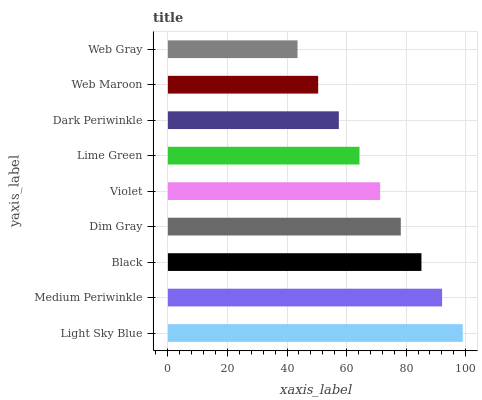Is Web Gray the minimum?
Answer yes or no. Yes. Is Light Sky Blue the maximum?
Answer yes or no. Yes. Is Medium Periwinkle the minimum?
Answer yes or no. No. Is Medium Periwinkle the maximum?
Answer yes or no. No. Is Light Sky Blue greater than Medium Periwinkle?
Answer yes or no. Yes. Is Medium Periwinkle less than Light Sky Blue?
Answer yes or no. Yes. Is Medium Periwinkle greater than Light Sky Blue?
Answer yes or no. No. Is Light Sky Blue less than Medium Periwinkle?
Answer yes or no. No. Is Violet the high median?
Answer yes or no. Yes. Is Violet the low median?
Answer yes or no. Yes. Is Light Sky Blue the high median?
Answer yes or no. No. Is Dim Gray the low median?
Answer yes or no. No. 